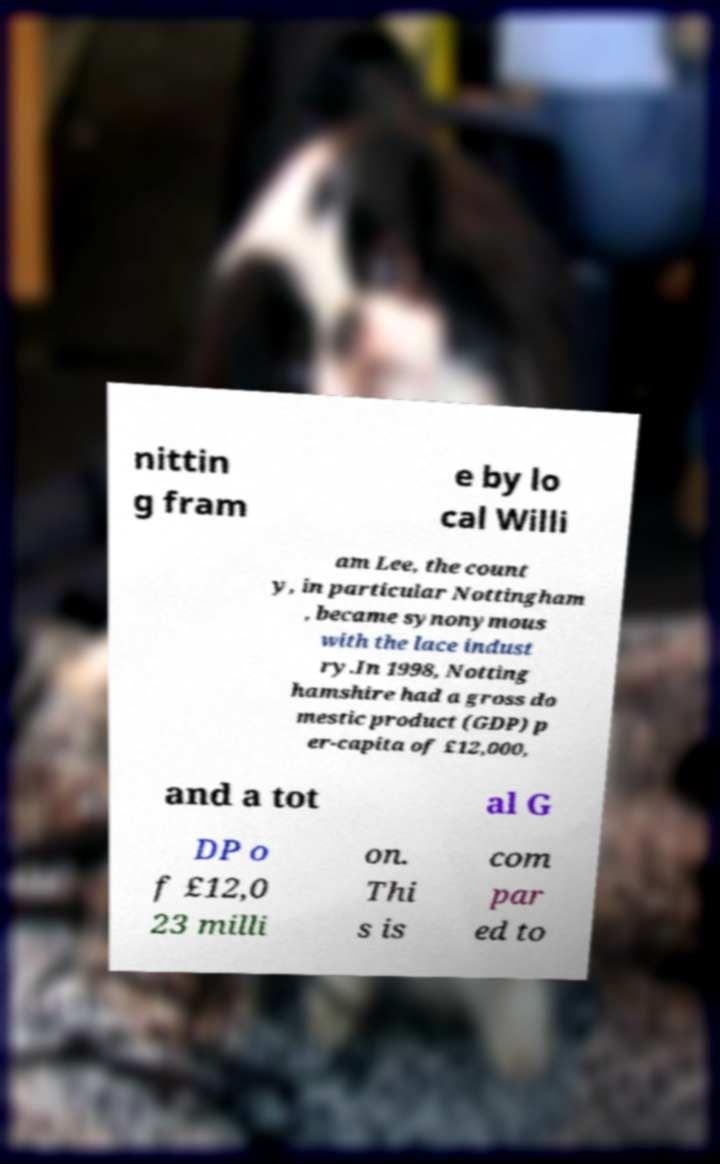Could you assist in decoding the text presented in this image and type it out clearly? nittin g fram e by lo cal Willi am Lee, the count y, in particular Nottingham , became synonymous with the lace indust ry.In 1998, Notting hamshire had a gross do mestic product (GDP) p er-capita of £12,000, and a tot al G DP o f £12,0 23 milli on. Thi s is com par ed to 